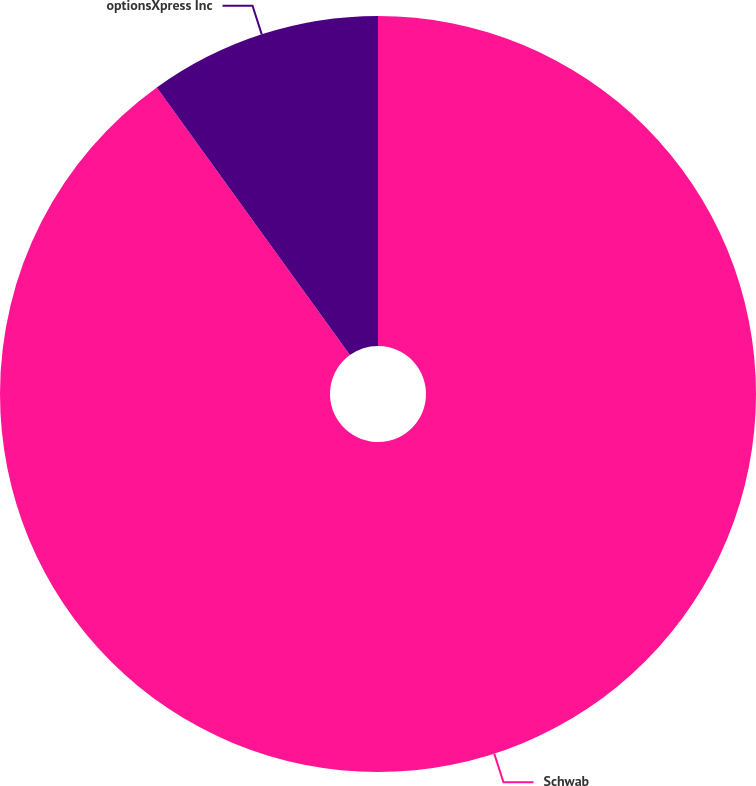<chart> <loc_0><loc_0><loc_500><loc_500><pie_chart><fcel>Schwab<fcel>optionsXpress Inc<nl><fcel>90.05%<fcel>9.95%<nl></chart> 